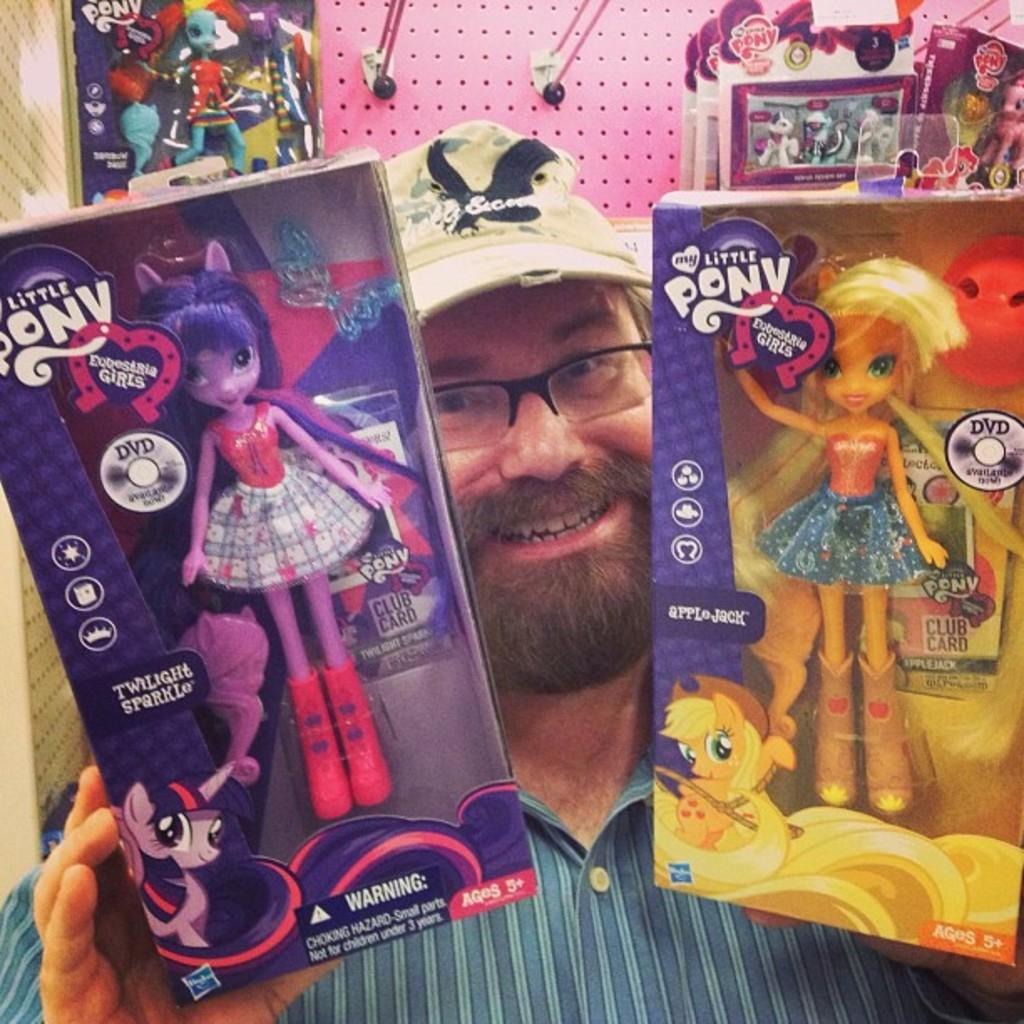What is the main subject of the image? There is a person in the image. What is the person doing in the image? The person is holding two toys, one in each hand. How does the person appear to feel in the image? The person has a smile on their face, suggesting they are happy or enjoying themselves. What can be seen in the background of the image? There are additional toys arranged in a rack in the background of the image. What type of breakfast is the person eating in the image? There is no breakfast visible in the image; the person is holding two toys. What committee is the person a part of in the image? There is no committee or any indication of a group activity in the image; it features a person holding toys. 